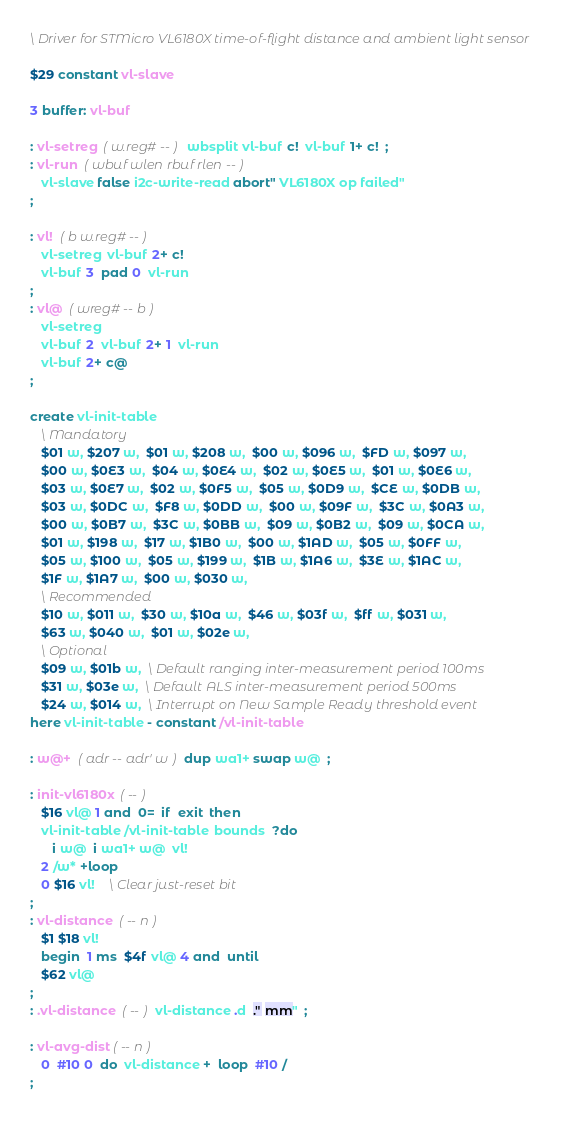Convert code to text. <code><loc_0><loc_0><loc_500><loc_500><_Forth_>\ Driver for STMicro VL6180X time-of-flight distance and ambient light sensor

$29 constant vl-slave

3 buffer: vl-buf

: vl-setreg  ( w.reg# -- )  wbsplit vl-buf c!  vl-buf 1+ c!  ;
: vl-run  ( wbuf wlen rbuf rlen -- )
   vl-slave false i2c-write-read abort" VL6180X op failed"
;

: vl!  ( b w.reg# -- )
   vl-setreg  vl-buf 2+ c!
   vl-buf 3  pad 0  vl-run
;   
: vl@  ( wreg# -- b )
   vl-setreg
   vl-buf 2  vl-buf 2+ 1  vl-run
   vl-buf 2+ c@
;

create vl-init-table
   \ Mandatory
   $01 w, $207 w,  $01 w, $208 w,  $00 w, $096 w,  $FD w, $097 w,
   $00 w, $0E3 w,  $04 w, $0E4 w,  $02 w, $0E5 w,  $01 w, $0E6 w,
   $03 w, $0E7 w,  $02 w, $0F5 w,  $05 w, $0D9 w,  $CE w, $0DB w,
   $03 w, $0DC w,  $F8 w, $0DD w,  $00 w, $09F w,  $3C w, $0A3 w,
   $00 w, $0B7 w,  $3C w, $0BB w,  $09 w, $0B2 w,  $09 w, $0CA w,
   $01 w, $198 w,  $17 w, $1B0 w,  $00 w, $1AD w,  $05 w, $0FF w,
   $05 w, $100 w,  $05 w, $199 w,  $1B w, $1A6 w,  $3E w, $1AC w,
   $1F w, $1A7 w,  $00 w, $030 w,
   \ Recommended
   $10 w, $011 w,  $30 w, $10a w,  $46 w, $03f w,  $ff w, $031 w,  
   $63 w, $040 w,  $01 w, $02e w,
   \ Optional
   $09 w, $01b w,  \ Default ranging inter-measurement period 100ms
   $31 w, $03e w,  \ Default ALS inter-measurement period 500ms
   $24 w, $014 w,  \ Interrupt on New Sample Ready threshold event
here vl-init-table - constant /vl-init-table

: w@+  ( adr -- adr' w )  dup wa1+ swap w@  ;

: init-vl6180x  ( -- )
   $16 vl@ 1 and  0=  if  exit  then
   vl-init-table /vl-init-table  bounds  ?do
      i w@  i wa1+ w@  vl!
   2 /w* +loop
   0 $16 vl!    \ Clear just-reset bit
;
: vl-distance  ( -- n )
   $1 $18 vl!
   begin  1 ms  $4f vl@ 4 and  until
   $62 vl@
;
: .vl-distance  ( -- )  vl-distance .d  ." mm"  ;

: vl-avg-dist ( -- n )
   0  #10 0  do  vl-distance +  loop  #10 /
;
</code> 